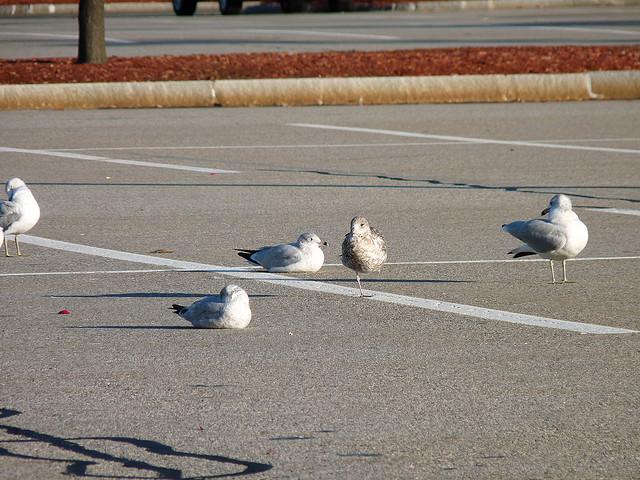Are the birds flying in the air?
Give a very brief answer. No. Is the horse running?
Give a very brief answer. No. How many birds are there in the picture?
Write a very short answer. 5. What type of birds are they?
Short answer required. Seagulls. How many bird legs can you see in this picture?
Short answer required. 5. 